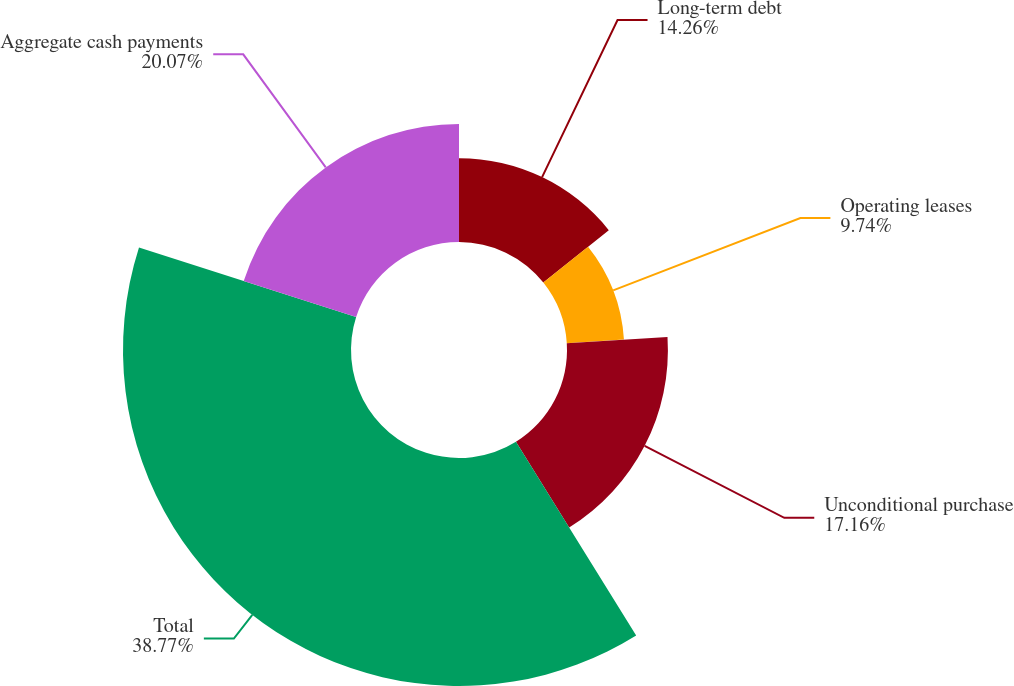Convert chart to OTSL. <chart><loc_0><loc_0><loc_500><loc_500><pie_chart><fcel>Long-term debt<fcel>Operating leases<fcel>Unconditional purchase<fcel>Total<fcel>Aggregate cash payments<nl><fcel>14.26%<fcel>9.74%<fcel>17.16%<fcel>38.77%<fcel>20.07%<nl></chart> 